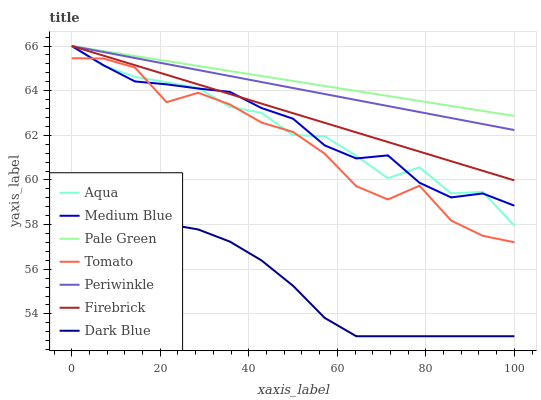Does Aqua have the minimum area under the curve?
Answer yes or no. No. Does Aqua have the maximum area under the curve?
Answer yes or no. No. Is Aqua the smoothest?
Answer yes or no. No. Is Aqua the roughest?
Answer yes or no. No. Does Aqua have the lowest value?
Answer yes or no. No. Does Dark Blue have the highest value?
Answer yes or no. No. Is Tomato less than Periwinkle?
Answer yes or no. Yes. Is Aqua greater than Dark Blue?
Answer yes or no. Yes. Does Tomato intersect Periwinkle?
Answer yes or no. No. 